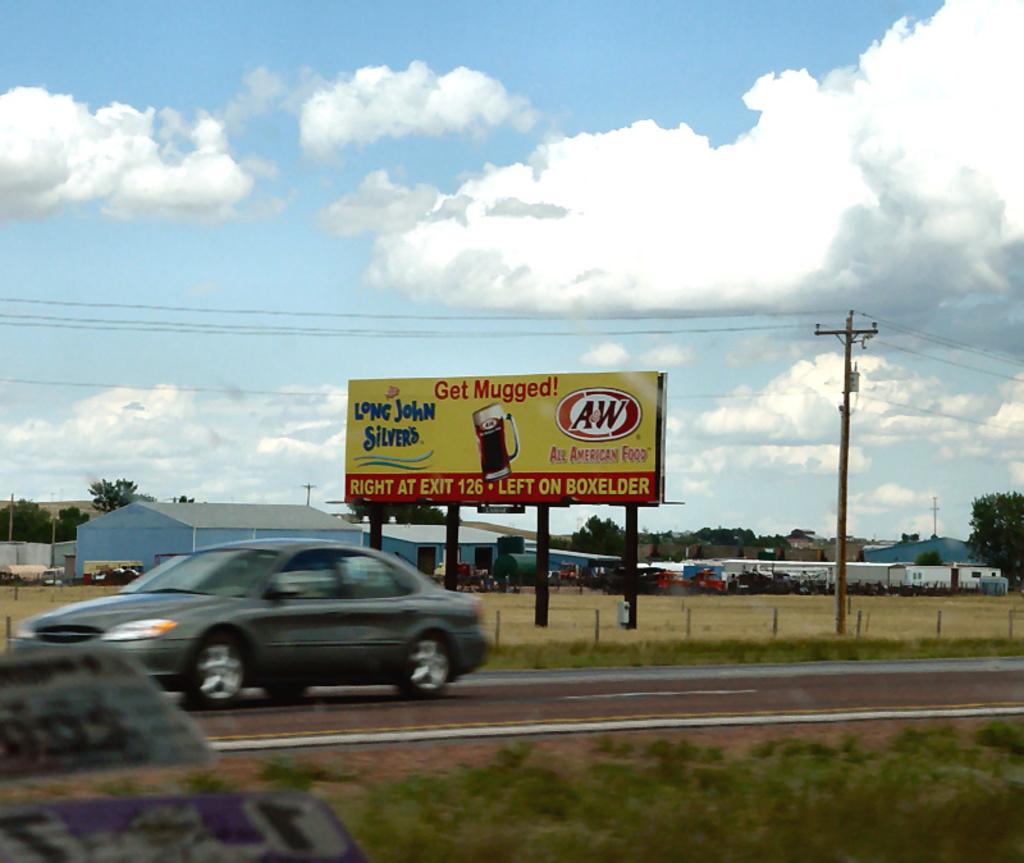What restaurant sign says, "get mugged"?
Offer a terse response. A&w. What restaurant name starts with long?
Your answer should be very brief. Long john silvers. 